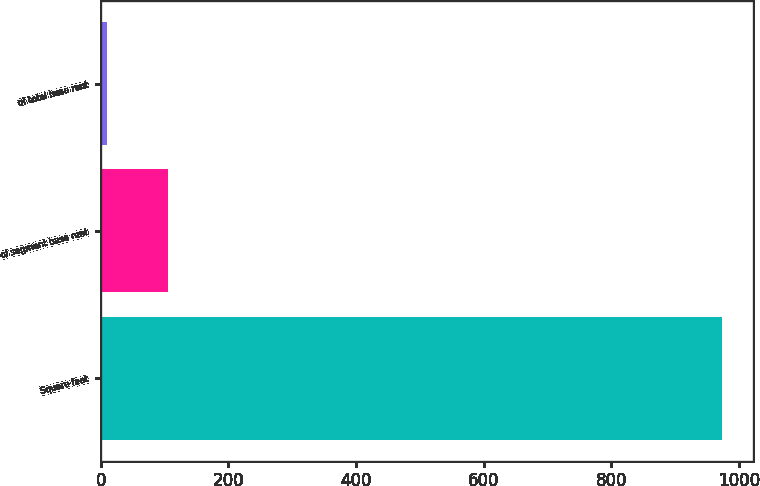Convert chart to OTSL. <chart><loc_0><loc_0><loc_500><loc_500><bar_chart><fcel>Square feet<fcel>of segment base rent<fcel>of total base rent<nl><fcel>974<fcel>105.5<fcel>9<nl></chart> 